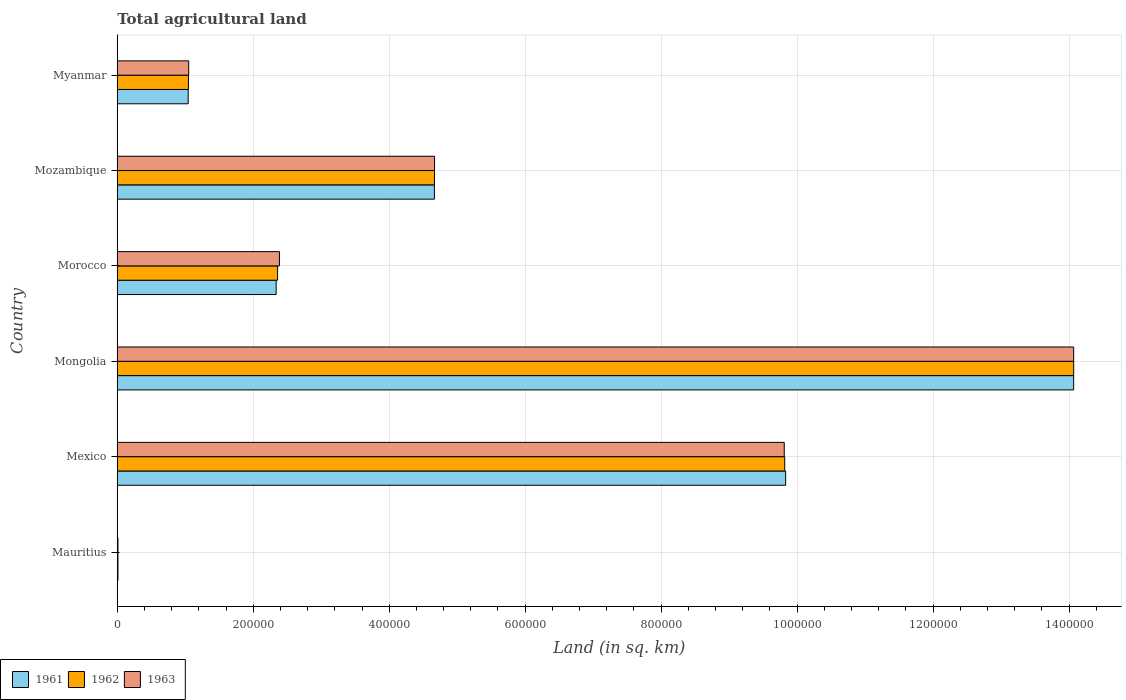How many groups of bars are there?
Keep it short and to the point. 6. How many bars are there on the 1st tick from the bottom?
Offer a very short reply. 3. What is the label of the 3rd group of bars from the top?
Provide a succinct answer. Morocco. What is the total agricultural land in 1961 in Mozambique?
Keep it short and to the point. 4.66e+05. Across all countries, what is the maximum total agricultural land in 1961?
Provide a short and direct response. 1.41e+06. Across all countries, what is the minimum total agricultural land in 1962?
Your answer should be compact. 1000. In which country was the total agricultural land in 1961 maximum?
Make the answer very short. Mongolia. In which country was the total agricultural land in 1963 minimum?
Make the answer very short. Mauritius. What is the total total agricultural land in 1962 in the graph?
Your response must be concise. 3.20e+06. What is the difference between the total agricultural land in 1961 in Mauritius and that in Myanmar?
Provide a short and direct response. -1.03e+05. What is the difference between the total agricultural land in 1963 in Mongolia and the total agricultural land in 1961 in Mexico?
Make the answer very short. 4.24e+05. What is the average total agricultural land in 1962 per country?
Offer a very short reply. 5.33e+05. What is the difference between the total agricultural land in 1963 and total agricultural land in 1961 in Mozambique?
Your answer should be compact. 210. What is the ratio of the total agricultural land in 1961 in Mauritius to that in Mexico?
Your answer should be very brief. 0. What is the difference between the highest and the second highest total agricultural land in 1962?
Provide a short and direct response. 4.25e+05. What is the difference between the highest and the lowest total agricultural land in 1963?
Offer a terse response. 1.41e+06. In how many countries, is the total agricultural land in 1961 greater than the average total agricultural land in 1961 taken over all countries?
Your response must be concise. 2. What does the 1st bar from the top in Morocco represents?
Your answer should be compact. 1963. What does the 1st bar from the bottom in Morocco represents?
Your answer should be compact. 1961. Is it the case that in every country, the sum of the total agricultural land in 1962 and total agricultural land in 1963 is greater than the total agricultural land in 1961?
Your answer should be compact. Yes. Are all the bars in the graph horizontal?
Provide a short and direct response. Yes. How many countries are there in the graph?
Your answer should be very brief. 6. What is the difference between two consecutive major ticks on the X-axis?
Your answer should be very brief. 2.00e+05. Are the values on the major ticks of X-axis written in scientific E-notation?
Your answer should be compact. No. How many legend labels are there?
Offer a very short reply. 3. How are the legend labels stacked?
Ensure brevity in your answer.  Horizontal. What is the title of the graph?
Your response must be concise. Total agricultural land. What is the label or title of the X-axis?
Your answer should be very brief. Land (in sq. km). What is the Land (in sq. km) of 1961 in Mauritius?
Make the answer very short. 990. What is the Land (in sq. km) in 1962 in Mauritius?
Offer a terse response. 1000. What is the Land (in sq. km) of 1963 in Mauritius?
Ensure brevity in your answer.  1000. What is the Land (in sq. km) in 1961 in Mexico?
Keep it short and to the point. 9.83e+05. What is the Land (in sq. km) in 1962 in Mexico?
Give a very brief answer. 9.82e+05. What is the Land (in sq. km) of 1963 in Mexico?
Offer a terse response. 9.81e+05. What is the Land (in sq. km) of 1961 in Mongolia?
Give a very brief answer. 1.41e+06. What is the Land (in sq. km) in 1962 in Mongolia?
Your response must be concise. 1.41e+06. What is the Land (in sq. km) of 1963 in Mongolia?
Offer a very short reply. 1.41e+06. What is the Land (in sq. km) of 1961 in Morocco?
Your response must be concise. 2.34e+05. What is the Land (in sq. km) in 1962 in Morocco?
Ensure brevity in your answer.  2.36e+05. What is the Land (in sq. km) of 1963 in Morocco?
Offer a terse response. 2.38e+05. What is the Land (in sq. km) in 1961 in Mozambique?
Give a very brief answer. 4.66e+05. What is the Land (in sq. km) in 1962 in Mozambique?
Your answer should be very brief. 4.67e+05. What is the Land (in sq. km) in 1963 in Mozambique?
Provide a short and direct response. 4.67e+05. What is the Land (in sq. km) of 1961 in Myanmar?
Provide a short and direct response. 1.04e+05. What is the Land (in sq. km) of 1962 in Myanmar?
Give a very brief answer. 1.05e+05. What is the Land (in sq. km) of 1963 in Myanmar?
Offer a terse response. 1.05e+05. Across all countries, what is the maximum Land (in sq. km) in 1961?
Make the answer very short. 1.41e+06. Across all countries, what is the maximum Land (in sq. km) in 1962?
Your answer should be compact. 1.41e+06. Across all countries, what is the maximum Land (in sq. km) in 1963?
Ensure brevity in your answer.  1.41e+06. Across all countries, what is the minimum Land (in sq. km) in 1961?
Ensure brevity in your answer.  990. Across all countries, what is the minimum Land (in sq. km) of 1962?
Give a very brief answer. 1000. Across all countries, what is the minimum Land (in sq. km) of 1963?
Offer a terse response. 1000. What is the total Land (in sq. km) in 1961 in the graph?
Keep it short and to the point. 3.20e+06. What is the total Land (in sq. km) in 1962 in the graph?
Your answer should be compact. 3.20e+06. What is the total Land (in sq. km) of 1963 in the graph?
Keep it short and to the point. 3.20e+06. What is the difference between the Land (in sq. km) of 1961 in Mauritius and that in Mexico?
Ensure brevity in your answer.  -9.82e+05. What is the difference between the Land (in sq. km) of 1962 in Mauritius and that in Mexico?
Your response must be concise. -9.81e+05. What is the difference between the Land (in sq. km) of 1963 in Mauritius and that in Mexico?
Provide a succinct answer. -9.80e+05. What is the difference between the Land (in sq. km) in 1961 in Mauritius and that in Mongolia?
Keep it short and to the point. -1.41e+06. What is the difference between the Land (in sq. km) of 1962 in Mauritius and that in Mongolia?
Make the answer very short. -1.41e+06. What is the difference between the Land (in sq. km) of 1963 in Mauritius and that in Mongolia?
Make the answer very short. -1.41e+06. What is the difference between the Land (in sq. km) of 1961 in Mauritius and that in Morocco?
Make the answer very short. -2.33e+05. What is the difference between the Land (in sq. km) of 1962 in Mauritius and that in Morocco?
Offer a terse response. -2.35e+05. What is the difference between the Land (in sq. km) of 1963 in Mauritius and that in Morocco?
Your answer should be compact. -2.38e+05. What is the difference between the Land (in sq. km) in 1961 in Mauritius and that in Mozambique?
Offer a very short reply. -4.66e+05. What is the difference between the Land (in sq. km) in 1962 in Mauritius and that in Mozambique?
Offer a very short reply. -4.66e+05. What is the difference between the Land (in sq. km) in 1963 in Mauritius and that in Mozambique?
Your answer should be compact. -4.66e+05. What is the difference between the Land (in sq. km) in 1961 in Mauritius and that in Myanmar?
Provide a succinct answer. -1.03e+05. What is the difference between the Land (in sq. km) of 1962 in Mauritius and that in Myanmar?
Your response must be concise. -1.04e+05. What is the difference between the Land (in sq. km) of 1963 in Mauritius and that in Myanmar?
Provide a succinct answer. -1.04e+05. What is the difference between the Land (in sq. km) of 1961 in Mexico and that in Mongolia?
Your response must be concise. -4.24e+05. What is the difference between the Land (in sq. km) of 1962 in Mexico and that in Mongolia?
Offer a very short reply. -4.25e+05. What is the difference between the Land (in sq. km) of 1963 in Mexico and that in Mongolia?
Provide a short and direct response. -4.26e+05. What is the difference between the Land (in sq. km) in 1961 in Mexico and that in Morocco?
Give a very brief answer. 7.49e+05. What is the difference between the Land (in sq. km) in 1962 in Mexico and that in Morocco?
Provide a short and direct response. 7.46e+05. What is the difference between the Land (in sq. km) of 1963 in Mexico and that in Morocco?
Offer a terse response. 7.43e+05. What is the difference between the Land (in sq. km) in 1961 in Mexico and that in Mozambique?
Offer a very short reply. 5.17e+05. What is the difference between the Land (in sq. km) in 1962 in Mexico and that in Mozambique?
Provide a succinct answer. 5.15e+05. What is the difference between the Land (in sq. km) of 1963 in Mexico and that in Mozambique?
Your answer should be compact. 5.14e+05. What is the difference between the Land (in sq. km) of 1961 in Mexico and that in Myanmar?
Provide a short and direct response. 8.79e+05. What is the difference between the Land (in sq. km) of 1962 in Mexico and that in Myanmar?
Keep it short and to the point. 8.77e+05. What is the difference between the Land (in sq. km) in 1963 in Mexico and that in Myanmar?
Your answer should be very brief. 8.76e+05. What is the difference between the Land (in sq. km) in 1961 in Mongolia and that in Morocco?
Your answer should be very brief. 1.17e+06. What is the difference between the Land (in sq. km) of 1962 in Mongolia and that in Morocco?
Ensure brevity in your answer.  1.17e+06. What is the difference between the Land (in sq. km) in 1963 in Mongolia and that in Morocco?
Your response must be concise. 1.17e+06. What is the difference between the Land (in sq. km) in 1961 in Mongolia and that in Mozambique?
Ensure brevity in your answer.  9.40e+05. What is the difference between the Land (in sq. km) of 1962 in Mongolia and that in Mozambique?
Offer a very short reply. 9.40e+05. What is the difference between the Land (in sq. km) of 1963 in Mongolia and that in Mozambique?
Give a very brief answer. 9.40e+05. What is the difference between the Land (in sq. km) in 1961 in Mongolia and that in Myanmar?
Provide a short and direct response. 1.30e+06. What is the difference between the Land (in sq. km) of 1962 in Mongolia and that in Myanmar?
Offer a very short reply. 1.30e+06. What is the difference between the Land (in sq. km) of 1963 in Mongolia and that in Myanmar?
Offer a terse response. 1.30e+06. What is the difference between the Land (in sq. km) of 1961 in Morocco and that in Mozambique?
Offer a very short reply. -2.33e+05. What is the difference between the Land (in sq. km) in 1962 in Morocco and that in Mozambique?
Offer a terse response. -2.31e+05. What is the difference between the Land (in sq. km) in 1963 in Morocco and that in Mozambique?
Make the answer very short. -2.28e+05. What is the difference between the Land (in sq. km) in 1961 in Morocco and that in Myanmar?
Your response must be concise. 1.29e+05. What is the difference between the Land (in sq. km) of 1962 in Morocco and that in Myanmar?
Give a very brief answer. 1.31e+05. What is the difference between the Land (in sq. km) of 1963 in Morocco and that in Myanmar?
Ensure brevity in your answer.  1.33e+05. What is the difference between the Land (in sq. km) in 1961 in Mozambique and that in Myanmar?
Keep it short and to the point. 3.62e+05. What is the difference between the Land (in sq. km) in 1962 in Mozambique and that in Myanmar?
Provide a succinct answer. 3.62e+05. What is the difference between the Land (in sq. km) of 1963 in Mozambique and that in Myanmar?
Your response must be concise. 3.62e+05. What is the difference between the Land (in sq. km) of 1961 in Mauritius and the Land (in sq. km) of 1962 in Mexico?
Offer a terse response. -9.81e+05. What is the difference between the Land (in sq. km) of 1961 in Mauritius and the Land (in sq. km) of 1963 in Mexico?
Provide a short and direct response. -9.80e+05. What is the difference between the Land (in sq. km) in 1962 in Mauritius and the Land (in sq. km) in 1963 in Mexico?
Provide a succinct answer. -9.80e+05. What is the difference between the Land (in sq. km) of 1961 in Mauritius and the Land (in sq. km) of 1962 in Mongolia?
Provide a succinct answer. -1.41e+06. What is the difference between the Land (in sq. km) in 1961 in Mauritius and the Land (in sq. km) in 1963 in Mongolia?
Offer a very short reply. -1.41e+06. What is the difference between the Land (in sq. km) of 1962 in Mauritius and the Land (in sq. km) of 1963 in Mongolia?
Provide a short and direct response. -1.41e+06. What is the difference between the Land (in sq. km) of 1961 in Mauritius and the Land (in sq. km) of 1962 in Morocco?
Keep it short and to the point. -2.35e+05. What is the difference between the Land (in sq. km) of 1961 in Mauritius and the Land (in sq. km) of 1963 in Morocco?
Provide a short and direct response. -2.38e+05. What is the difference between the Land (in sq. km) of 1962 in Mauritius and the Land (in sq. km) of 1963 in Morocco?
Your answer should be compact. -2.38e+05. What is the difference between the Land (in sq. km) of 1961 in Mauritius and the Land (in sq. km) of 1962 in Mozambique?
Give a very brief answer. -4.66e+05. What is the difference between the Land (in sq. km) of 1961 in Mauritius and the Land (in sq. km) of 1963 in Mozambique?
Offer a terse response. -4.66e+05. What is the difference between the Land (in sq. km) of 1962 in Mauritius and the Land (in sq. km) of 1963 in Mozambique?
Make the answer very short. -4.66e+05. What is the difference between the Land (in sq. km) of 1961 in Mauritius and the Land (in sq. km) of 1962 in Myanmar?
Offer a terse response. -1.04e+05. What is the difference between the Land (in sq. km) of 1961 in Mauritius and the Land (in sq. km) of 1963 in Myanmar?
Give a very brief answer. -1.04e+05. What is the difference between the Land (in sq. km) of 1962 in Mauritius and the Land (in sq. km) of 1963 in Myanmar?
Keep it short and to the point. -1.04e+05. What is the difference between the Land (in sq. km) of 1961 in Mexico and the Land (in sq. km) of 1962 in Mongolia?
Give a very brief answer. -4.24e+05. What is the difference between the Land (in sq. km) of 1961 in Mexico and the Land (in sq. km) of 1963 in Mongolia?
Keep it short and to the point. -4.24e+05. What is the difference between the Land (in sq. km) in 1962 in Mexico and the Land (in sq. km) in 1963 in Mongolia?
Ensure brevity in your answer.  -4.25e+05. What is the difference between the Land (in sq. km) of 1961 in Mexico and the Land (in sq. km) of 1962 in Morocco?
Give a very brief answer. 7.47e+05. What is the difference between the Land (in sq. km) in 1961 in Mexico and the Land (in sq. km) in 1963 in Morocco?
Your answer should be compact. 7.45e+05. What is the difference between the Land (in sq. km) of 1962 in Mexico and the Land (in sq. km) of 1963 in Morocco?
Give a very brief answer. 7.43e+05. What is the difference between the Land (in sq. km) of 1961 in Mexico and the Land (in sq. km) of 1962 in Mozambique?
Ensure brevity in your answer.  5.17e+05. What is the difference between the Land (in sq. km) in 1961 in Mexico and the Land (in sq. km) in 1963 in Mozambique?
Keep it short and to the point. 5.16e+05. What is the difference between the Land (in sq. km) in 1962 in Mexico and the Land (in sq. km) in 1963 in Mozambique?
Your answer should be very brief. 5.15e+05. What is the difference between the Land (in sq. km) in 1961 in Mexico and the Land (in sq. km) in 1962 in Myanmar?
Your answer should be compact. 8.78e+05. What is the difference between the Land (in sq. km) in 1961 in Mexico and the Land (in sq. km) in 1963 in Myanmar?
Ensure brevity in your answer.  8.78e+05. What is the difference between the Land (in sq. km) of 1962 in Mexico and the Land (in sq. km) of 1963 in Myanmar?
Ensure brevity in your answer.  8.77e+05. What is the difference between the Land (in sq. km) in 1961 in Mongolia and the Land (in sq. km) in 1962 in Morocco?
Keep it short and to the point. 1.17e+06. What is the difference between the Land (in sq. km) in 1961 in Mongolia and the Land (in sq. km) in 1963 in Morocco?
Your answer should be compact. 1.17e+06. What is the difference between the Land (in sq. km) of 1962 in Mongolia and the Land (in sq. km) of 1963 in Morocco?
Provide a succinct answer. 1.17e+06. What is the difference between the Land (in sq. km) of 1961 in Mongolia and the Land (in sq. km) of 1962 in Mozambique?
Your answer should be compact. 9.40e+05. What is the difference between the Land (in sq. km) in 1961 in Mongolia and the Land (in sq. km) in 1963 in Mozambique?
Offer a terse response. 9.40e+05. What is the difference between the Land (in sq. km) of 1962 in Mongolia and the Land (in sq. km) of 1963 in Mozambique?
Provide a succinct answer. 9.40e+05. What is the difference between the Land (in sq. km) of 1961 in Mongolia and the Land (in sq. km) of 1962 in Myanmar?
Your answer should be very brief. 1.30e+06. What is the difference between the Land (in sq. km) in 1961 in Mongolia and the Land (in sq. km) in 1963 in Myanmar?
Give a very brief answer. 1.30e+06. What is the difference between the Land (in sq. km) of 1962 in Mongolia and the Land (in sq. km) of 1963 in Myanmar?
Offer a very short reply. 1.30e+06. What is the difference between the Land (in sq. km) in 1961 in Morocco and the Land (in sq. km) in 1962 in Mozambique?
Your response must be concise. -2.33e+05. What is the difference between the Land (in sq. km) of 1961 in Morocco and the Land (in sq. km) of 1963 in Mozambique?
Offer a very short reply. -2.33e+05. What is the difference between the Land (in sq. km) in 1962 in Morocco and the Land (in sq. km) in 1963 in Mozambique?
Offer a terse response. -2.31e+05. What is the difference between the Land (in sq. km) of 1961 in Morocco and the Land (in sq. km) of 1962 in Myanmar?
Your response must be concise. 1.29e+05. What is the difference between the Land (in sq. km) in 1961 in Morocco and the Land (in sq. km) in 1963 in Myanmar?
Keep it short and to the point. 1.29e+05. What is the difference between the Land (in sq. km) of 1962 in Morocco and the Land (in sq. km) of 1963 in Myanmar?
Offer a very short reply. 1.31e+05. What is the difference between the Land (in sq. km) of 1961 in Mozambique and the Land (in sq. km) of 1962 in Myanmar?
Keep it short and to the point. 3.62e+05. What is the difference between the Land (in sq. km) of 1961 in Mozambique and the Land (in sq. km) of 1963 in Myanmar?
Your answer should be compact. 3.61e+05. What is the difference between the Land (in sq. km) in 1962 in Mozambique and the Land (in sq. km) in 1963 in Myanmar?
Keep it short and to the point. 3.62e+05. What is the average Land (in sq. km) in 1961 per country?
Keep it short and to the point. 5.33e+05. What is the average Land (in sq. km) in 1962 per country?
Your answer should be very brief. 5.33e+05. What is the average Land (in sq. km) of 1963 per country?
Offer a terse response. 5.33e+05. What is the difference between the Land (in sq. km) in 1961 and Land (in sq. km) in 1962 in Mexico?
Give a very brief answer. 1370. What is the difference between the Land (in sq. km) in 1961 and Land (in sq. km) in 1963 in Mexico?
Your answer should be compact. 2070. What is the difference between the Land (in sq. km) in 1962 and Land (in sq. km) in 1963 in Mexico?
Give a very brief answer. 700. What is the difference between the Land (in sq. km) in 1961 and Land (in sq. km) in 1963 in Mongolia?
Your answer should be compact. 0. What is the difference between the Land (in sq. km) in 1962 and Land (in sq. km) in 1963 in Mongolia?
Give a very brief answer. 0. What is the difference between the Land (in sq. km) of 1961 and Land (in sq. km) of 1962 in Morocco?
Keep it short and to the point. -2100. What is the difference between the Land (in sq. km) in 1961 and Land (in sq. km) in 1963 in Morocco?
Ensure brevity in your answer.  -4800. What is the difference between the Land (in sq. km) of 1962 and Land (in sq. km) of 1963 in Morocco?
Your answer should be very brief. -2700. What is the difference between the Land (in sq. km) in 1961 and Land (in sq. km) in 1962 in Mozambique?
Your response must be concise. -110. What is the difference between the Land (in sq. km) of 1961 and Land (in sq. km) of 1963 in Mozambique?
Give a very brief answer. -210. What is the difference between the Land (in sq. km) of 1962 and Land (in sq. km) of 1963 in Mozambique?
Provide a succinct answer. -100. What is the difference between the Land (in sq. km) in 1961 and Land (in sq. km) in 1962 in Myanmar?
Offer a very short reply. -400. What is the difference between the Land (in sq. km) of 1961 and Land (in sq. km) of 1963 in Myanmar?
Provide a short and direct response. -770. What is the difference between the Land (in sq. km) in 1962 and Land (in sq. km) in 1963 in Myanmar?
Offer a very short reply. -370. What is the ratio of the Land (in sq. km) in 1963 in Mauritius to that in Mexico?
Ensure brevity in your answer.  0. What is the ratio of the Land (in sq. km) of 1961 in Mauritius to that in Mongolia?
Give a very brief answer. 0. What is the ratio of the Land (in sq. km) of 1962 in Mauritius to that in Mongolia?
Ensure brevity in your answer.  0. What is the ratio of the Land (in sq. km) in 1963 in Mauritius to that in Mongolia?
Your answer should be compact. 0. What is the ratio of the Land (in sq. km) of 1961 in Mauritius to that in Morocco?
Provide a short and direct response. 0. What is the ratio of the Land (in sq. km) of 1962 in Mauritius to that in Morocco?
Provide a succinct answer. 0. What is the ratio of the Land (in sq. km) in 1963 in Mauritius to that in Morocco?
Offer a terse response. 0. What is the ratio of the Land (in sq. km) of 1961 in Mauritius to that in Mozambique?
Your response must be concise. 0. What is the ratio of the Land (in sq. km) of 1962 in Mauritius to that in Mozambique?
Ensure brevity in your answer.  0. What is the ratio of the Land (in sq. km) of 1963 in Mauritius to that in Mozambique?
Provide a succinct answer. 0. What is the ratio of the Land (in sq. km) of 1961 in Mauritius to that in Myanmar?
Your answer should be compact. 0.01. What is the ratio of the Land (in sq. km) in 1962 in Mauritius to that in Myanmar?
Your response must be concise. 0.01. What is the ratio of the Land (in sq. km) in 1963 in Mauritius to that in Myanmar?
Make the answer very short. 0.01. What is the ratio of the Land (in sq. km) of 1961 in Mexico to that in Mongolia?
Your answer should be compact. 0.7. What is the ratio of the Land (in sq. km) in 1962 in Mexico to that in Mongolia?
Offer a very short reply. 0.7. What is the ratio of the Land (in sq. km) of 1963 in Mexico to that in Mongolia?
Ensure brevity in your answer.  0.7. What is the ratio of the Land (in sq. km) in 1961 in Mexico to that in Morocco?
Your response must be concise. 4.21. What is the ratio of the Land (in sq. km) of 1962 in Mexico to that in Morocco?
Your answer should be compact. 4.16. What is the ratio of the Land (in sq. km) of 1963 in Mexico to that in Morocco?
Offer a terse response. 4.11. What is the ratio of the Land (in sq. km) in 1961 in Mexico to that in Mozambique?
Your answer should be compact. 2.11. What is the ratio of the Land (in sq. km) in 1962 in Mexico to that in Mozambique?
Your response must be concise. 2.1. What is the ratio of the Land (in sq. km) in 1963 in Mexico to that in Mozambique?
Provide a short and direct response. 2.1. What is the ratio of the Land (in sq. km) of 1961 in Mexico to that in Myanmar?
Provide a short and direct response. 9.43. What is the ratio of the Land (in sq. km) in 1962 in Mexico to that in Myanmar?
Provide a succinct answer. 9.38. What is the ratio of the Land (in sq. km) of 1963 in Mexico to that in Myanmar?
Make the answer very short. 9.34. What is the ratio of the Land (in sq. km) of 1961 in Mongolia to that in Morocco?
Your response must be concise. 6.02. What is the ratio of the Land (in sq. km) in 1962 in Mongolia to that in Morocco?
Offer a terse response. 5.97. What is the ratio of the Land (in sq. km) in 1963 in Mongolia to that in Morocco?
Provide a short and direct response. 5.9. What is the ratio of the Land (in sq. km) in 1961 in Mongolia to that in Mozambique?
Make the answer very short. 3.02. What is the ratio of the Land (in sq. km) in 1962 in Mongolia to that in Mozambique?
Your answer should be compact. 3.02. What is the ratio of the Land (in sq. km) in 1963 in Mongolia to that in Mozambique?
Offer a very short reply. 3.01. What is the ratio of the Land (in sq. km) of 1961 in Mongolia to that in Myanmar?
Your answer should be compact. 13.49. What is the ratio of the Land (in sq. km) of 1962 in Mongolia to that in Myanmar?
Provide a short and direct response. 13.44. What is the ratio of the Land (in sq. km) in 1963 in Mongolia to that in Myanmar?
Ensure brevity in your answer.  13.39. What is the ratio of the Land (in sq. km) in 1961 in Morocco to that in Mozambique?
Your response must be concise. 0.5. What is the ratio of the Land (in sq. km) in 1962 in Morocco to that in Mozambique?
Your answer should be compact. 0.51. What is the ratio of the Land (in sq. km) of 1963 in Morocco to that in Mozambique?
Keep it short and to the point. 0.51. What is the ratio of the Land (in sq. km) in 1961 in Morocco to that in Myanmar?
Make the answer very short. 2.24. What is the ratio of the Land (in sq. km) in 1962 in Morocco to that in Myanmar?
Your answer should be compact. 2.25. What is the ratio of the Land (in sq. km) in 1963 in Morocco to that in Myanmar?
Ensure brevity in your answer.  2.27. What is the ratio of the Land (in sq. km) of 1961 in Mozambique to that in Myanmar?
Provide a succinct answer. 4.47. What is the ratio of the Land (in sq. km) of 1962 in Mozambique to that in Myanmar?
Your response must be concise. 4.46. What is the ratio of the Land (in sq. km) in 1963 in Mozambique to that in Myanmar?
Offer a very short reply. 4.44. What is the difference between the highest and the second highest Land (in sq. km) in 1961?
Ensure brevity in your answer.  4.24e+05. What is the difference between the highest and the second highest Land (in sq. km) of 1962?
Offer a very short reply. 4.25e+05. What is the difference between the highest and the second highest Land (in sq. km) of 1963?
Provide a succinct answer. 4.26e+05. What is the difference between the highest and the lowest Land (in sq. km) in 1961?
Provide a short and direct response. 1.41e+06. What is the difference between the highest and the lowest Land (in sq. km) in 1962?
Your answer should be compact. 1.41e+06. What is the difference between the highest and the lowest Land (in sq. km) in 1963?
Offer a terse response. 1.41e+06. 